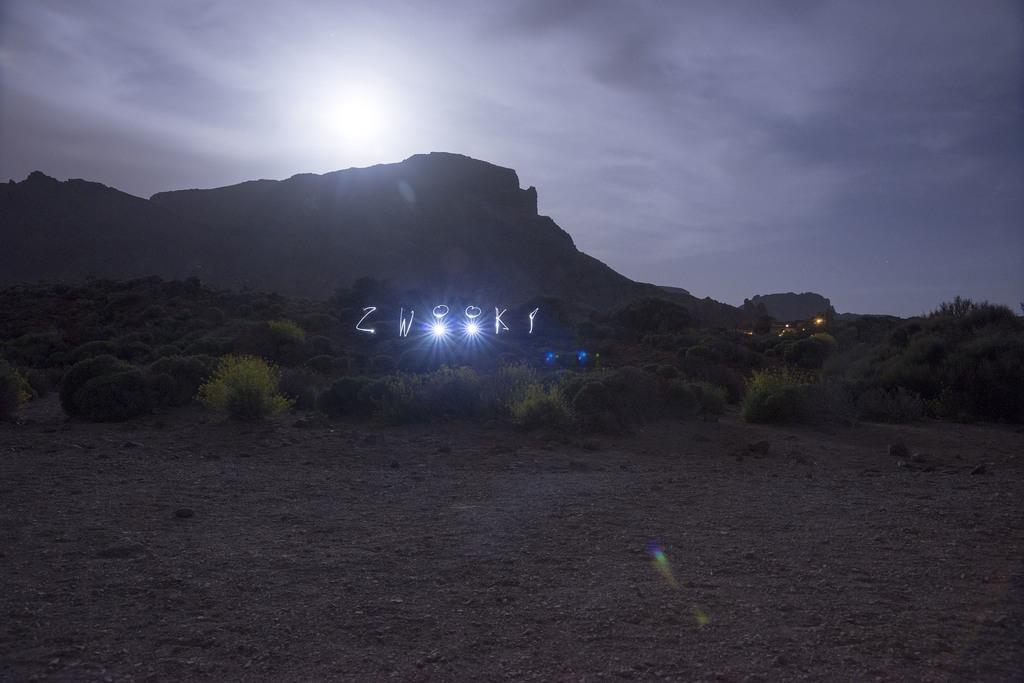Could you give a brief overview of what you see in this image? In this image, we can see hills, lights, shrubs, trees and at the top, there is moon light in the sky. At the bottom, there is ground. 